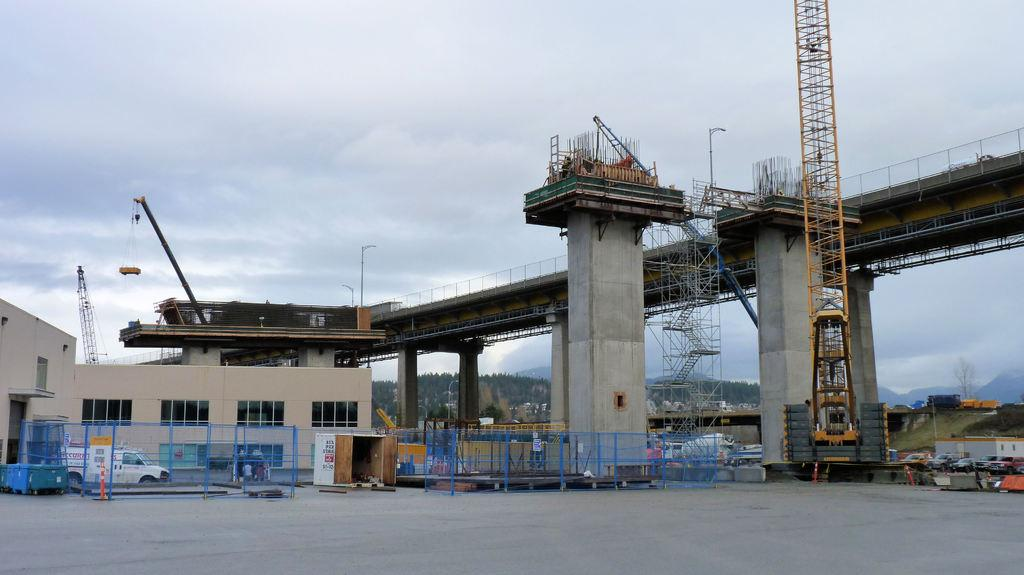What type of structures can be seen in the image? There are pillars and a building with windows in the image. What type of transportation is visible in the image? There is a vehicle on the ground in the image. What type of natural features can be seen in the image? There are trees, mountains, and clouds in the sky in the image. What type of environment is depicted in the image? The image shows a combination of natural and man-made elements, including a bridge, trees, mountains, and a building. Are there any living beings present in the image? Yes, there are people in the image. What is visible in the background of the image? The sky is visible in the background of the image, with clouds present. What type of pets can be seen playing with the people in the image? There are no pets visible in the image; only people, pillars, a bridge, a building, trees, mountains, a vehicle, and clouds are present. How does the bridge pull the mountains closer together in the image? The bridge does not have the ability to pull the mountains closer together; it is a stationary structure connecting two points. 